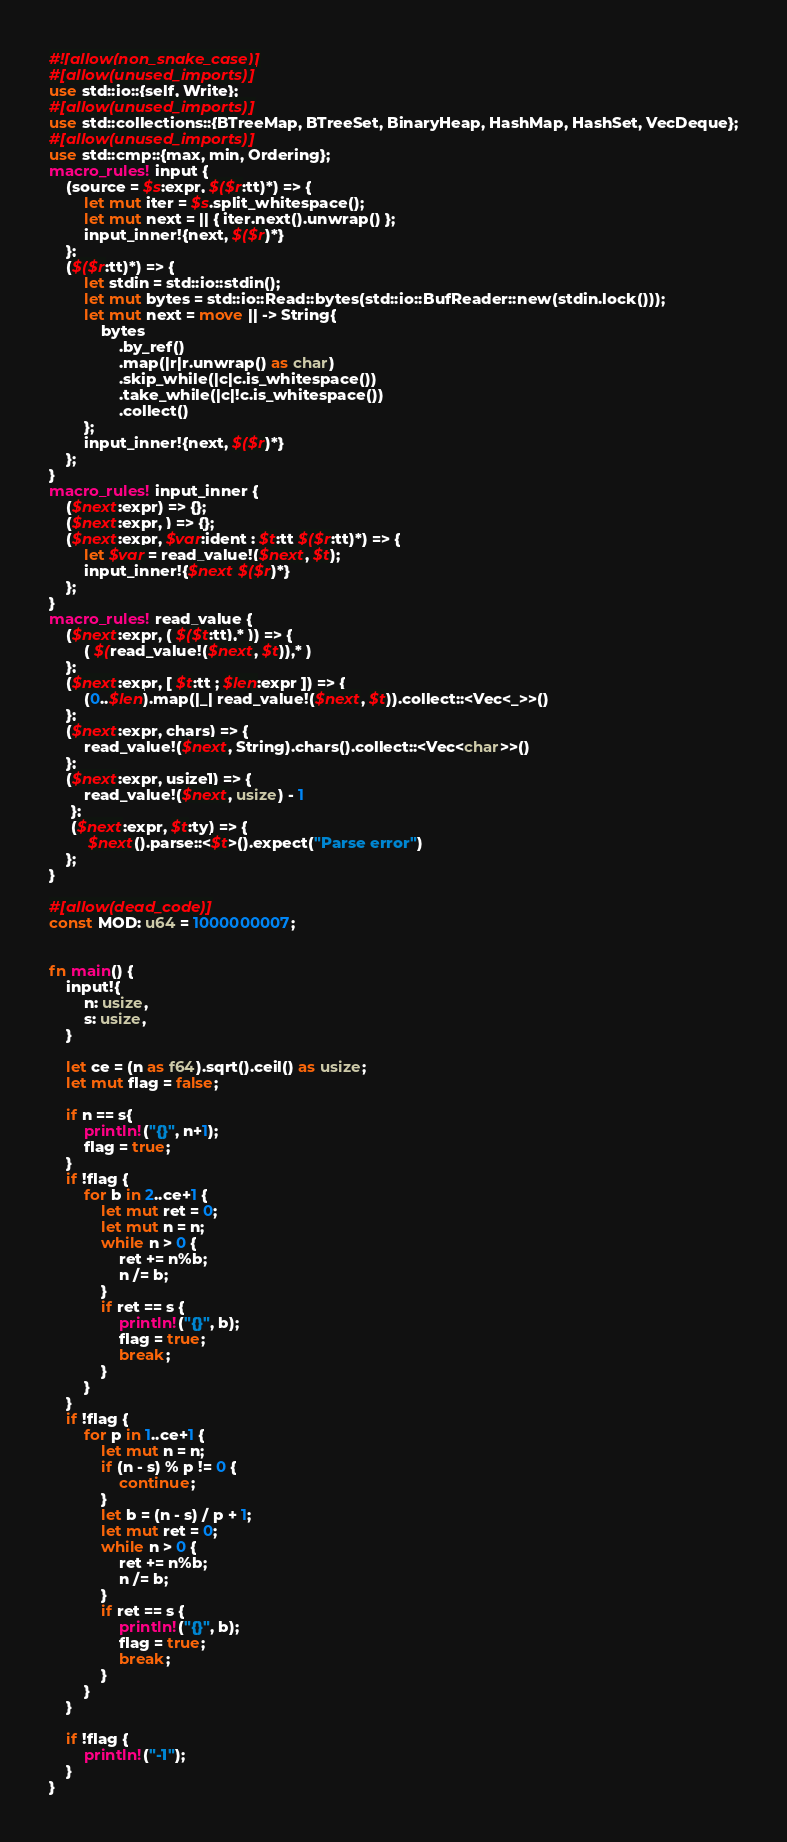Convert code to text. <code><loc_0><loc_0><loc_500><loc_500><_Rust_>#![allow(non_snake_case)]
#[allow(unused_imports)]
use std::io::{self, Write};
#[allow(unused_imports)]
use std::collections::{BTreeMap, BTreeSet, BinaryHeap, HashMap, HashSet, VecDeque};
#[allow(unused_imports)]
use std::cmp::{max, min, Ordering};
macro_rules! input {
    (source = $s:expr, $($r:tt)*) => {
        let mut iter = $s.split_whitespace();
        let mut next = || { iter.next().unwrap() };
        input_inner!{next, $($r)*}
    };
    ($($r:tt)*) => {
        let stdin = std::io::stdin();
        let mut bytes = std::io::Read::bytes(std::io::BufReader::new(stdin.lock()));
        let mut next = move || -> String{
            bytes
                .by_ref()
                .map(|r|r.unwrap() as char)
                .skip_while(|c|c.is_whitespace())
                .take_while(|c|!c.is_whitespace())
                .collect()
        };
        input_inner!{next, $($r)*}
    };
}
macro_rules! input_inner {
    ($next:expr) => {};
    ($next:expr, ) => {};
    ($next:expr, $var:ident : $t:tt $($r:tt)*) => {
        let $var = read_value!($next, $t);
        input_inner!{$next $($r)*}
    };
}
macro_rules! read_value {
    ($next:expr, ( $($t:tt),* )) => {
        ( $(read_value!($next, $t)),* )
    };
    ($next:expr, [ $t:tt ; $len:expr ]) => {
        (0..$len).map(|_| read_value!($next, $t)).collect::<Vec<_>>()
    };
    ($next:expr, chars) => {
        read_value!($next, String).chars().collect::<Vec<char>>()
    };
    ($next:expr, usize1) => {
        read_value!($next, usize) - 1
     };
     ($next:expr, $t:ty) => {
         $next().parse::<$t>().expect("Parse error")
    };
}

#[allow(dead_code)]
const MOD: u64 = 1000000007;


fn main() {
    input!{
        n: usize,
        s: usize,
    }

    let ce = (n as f64).sqrt().ceil() as usize;
    let mut flag = false;

    if n == s{
        println!("{}", n+1);
        flag = true;
    }
    if !flag {
        for b in 2..ce+1 {
            let mut ret = 0;
            let mut n = n;
            while n > 0 {
                ret += n%b;
                n /= b;
            }
            if ret == s {
                println!("{}", b);
                flag = true;
                break;
            }
        }
    }
    if !flag {
        for p in 1..ce+1 {
            let mut n = n;
            if (n - s) % p != 0 {
                continue;
            }
            let b = (n - s) / p + 1;
            let mut ret = 0;
            while n > 0 {
                ret += n%b;
                n /= b;
            }
            if ret == s {
                println!("{}", b);
                flag = true;
                break;
            }
        }
    }

    if !flag {
        println!("-1");
    }
}</code> 